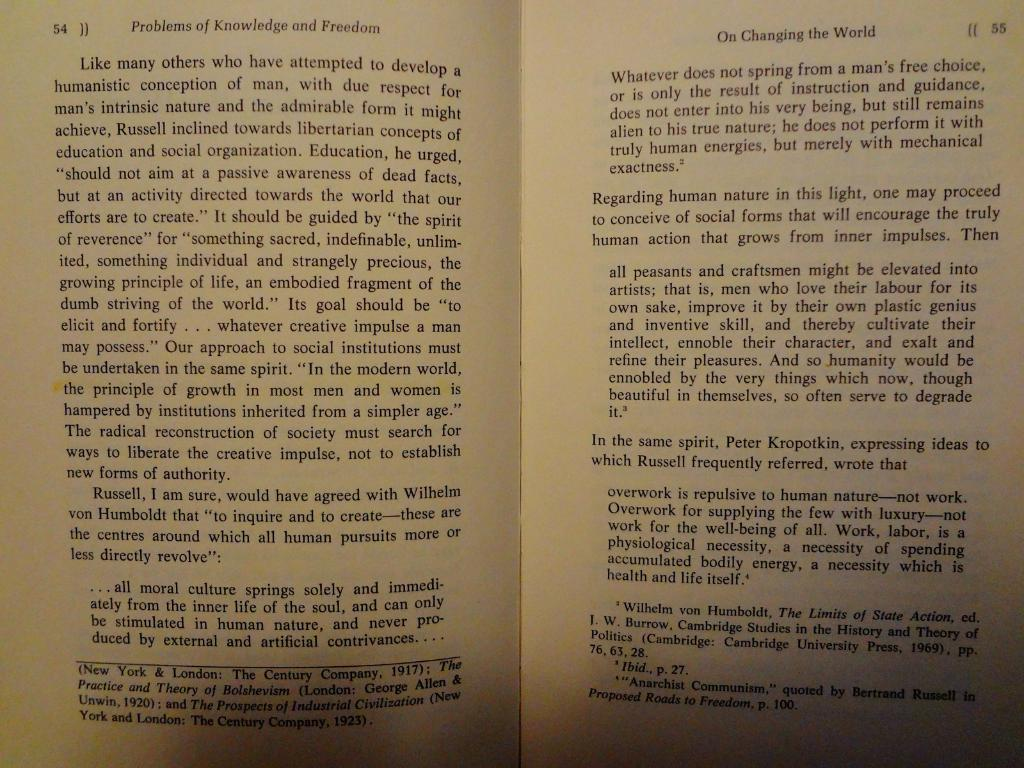Provide a one-sentence caption for the provided image. Two pages from a book on changing the world. 